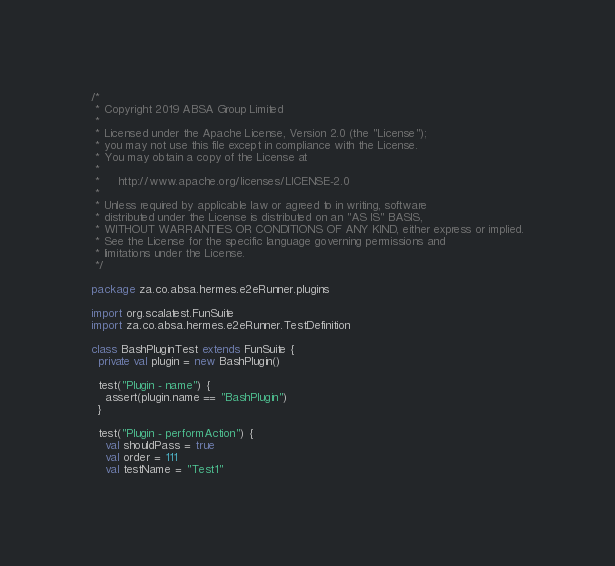Convert code to text. <code><loc_0><loc_0><loc_500><loc_500><_Scala_>/*
 * Copyright 2019 ABSA Group Limited
 *
 * Licensed under the Apache License, Version 2.0 (the "License");
 * you may not use this file except in compliance with the License.
 * You may obtain a copy of the License at
 *
 *     http://www.apache.org/licenses/LICENSE-2.0
 *
 * Unless required by applicable law or agreed to in writing, software
 * distributed under the License is distributed on an "AS IS" BASIS,
 * WITHOUT WARRANTIES OR CONDITIONS OF ANY KIND, either express or implied.
 * See the License for the specific language governing permissions and
 * limitations under the License.
 */

package za.co.absa.hermes.e2eRunner.plugins

import org.scalatest.FunSuite
import za.co.absa.hermes.e2eRunner.TestDefinition

class BashPluginTest extends FunSuite {
  private val plugin = new BashPlugin()

  test("Plugin - name") {
    assert(plugin.name == "BashPlugin")
  }

  test("Plugin - performAction") {
    val shouldPass = true
    val order = 111
    val testName = "Test1"</code> 